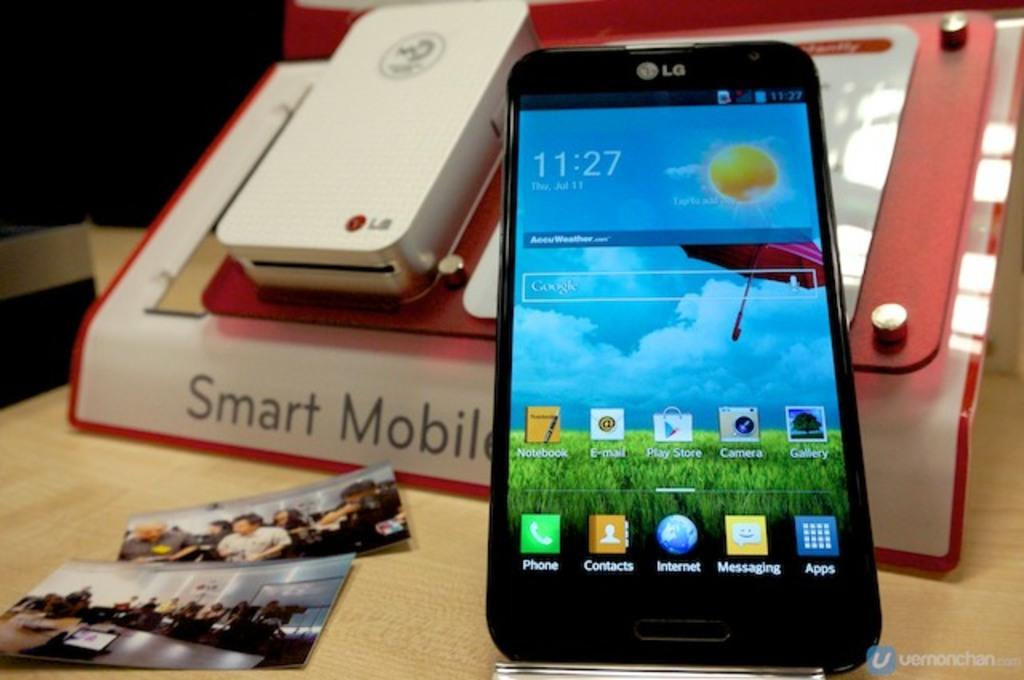<image>
Write a terse but informative summary of the picture. 11:27 is what the digital clock displays on this smart phone. 